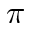Convert formula to latex. <formula><loc_0><loc_0><loc_500><loc_500>\pi</formula> 